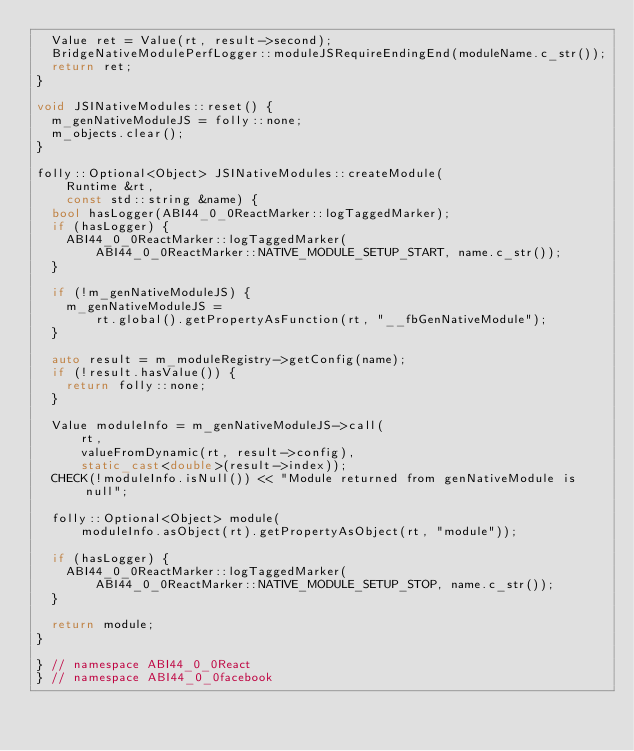<code> <loc_0><loc_0><loc_500><loc_500><_C++_>  Value ret = Value(rt, result->second);
  BridgeNativeModulePerfLogger::moduleJSRequireEndingEnd(moduleName.c_str());
  return ret;
}

void JSINativeModules::reset() {
  m_genNativeModuleJS = folly::none;
  m_objects.clear();
}

folly::Optional<Object> JSINativeModules::createModule(
    Runtime &rt,
    const std::string &name) {
  bool hasLogger(ABI44_0_0ReactMarker::logTaggedMarker);
  if (hasLogger) {
    ABI44_0_0ReactMarker::logTaggedMarker(
        ABI44_0_0ReactMarker::NATIVE_MODULE_SETUP_START, name.c_str());
  }

  if (!m_genNativeModuleJS) {
    m_genNativeModuleJS =
        rt.global().getPropertyAsFunction(rt, "__fbGenNativeModule");
  }

  auto result = m_moduleRegistry->getConfig(name);
  if (!result.hasValue()) {
    return folly::none;
  }

  Value moduleInfo = m_genNativeModuleJS->call(
      rt,
      valueFromDynamic(rt, result->config),
      static_cast<double>(result->index));
  CHECK(!moduleInfo.isNull()) << "Module returned from genNativeModule is null";

  folly::Optional<Object> module(
      moduleInfo.asObject(rt).getPropertyAsObject(rt, "module"));

  if (hasLogger) {
    ABI44_0_0ReactMarker::logTaggedMarker(
        ABI44_0_0ReactMarker::NATIVE_MODULE_SETUP_STOP, name.c_str());
  }

  return module;
}

} // namespace ABI44_0_0React
} // namespace ABI44_0_0facebook
</code> 